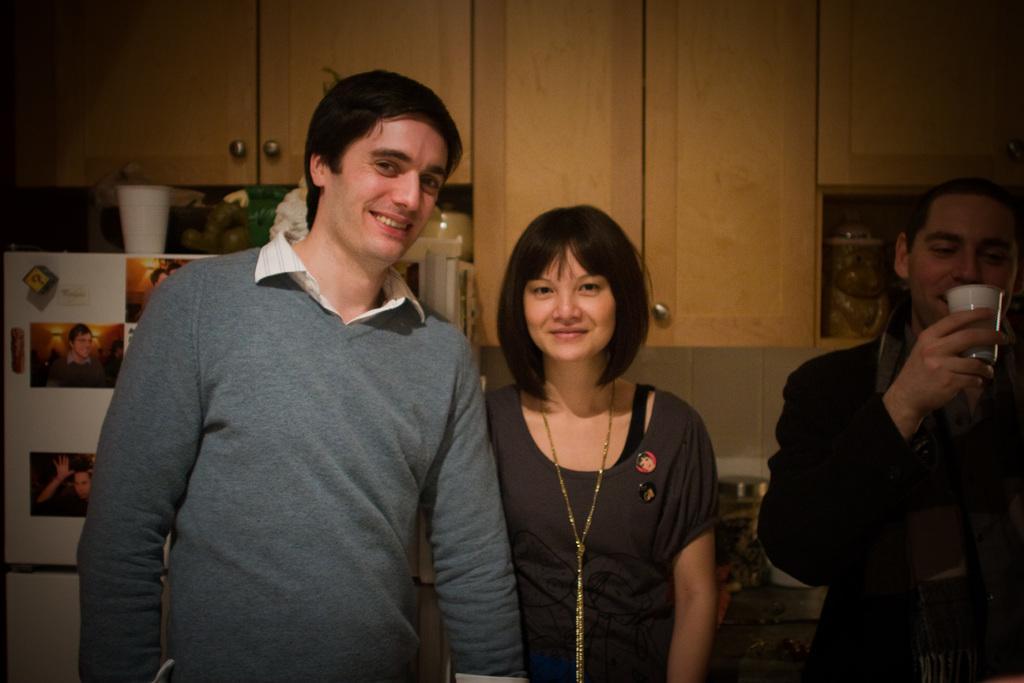In one or two sentences, can you explain what this image depicts? In the picture I can see two men and a woman are standing among them the man on the right side is holding a white color glass in the hand. In the background I can see wooden cupboards, a refrigerator which has some objects on it and some other objects. 